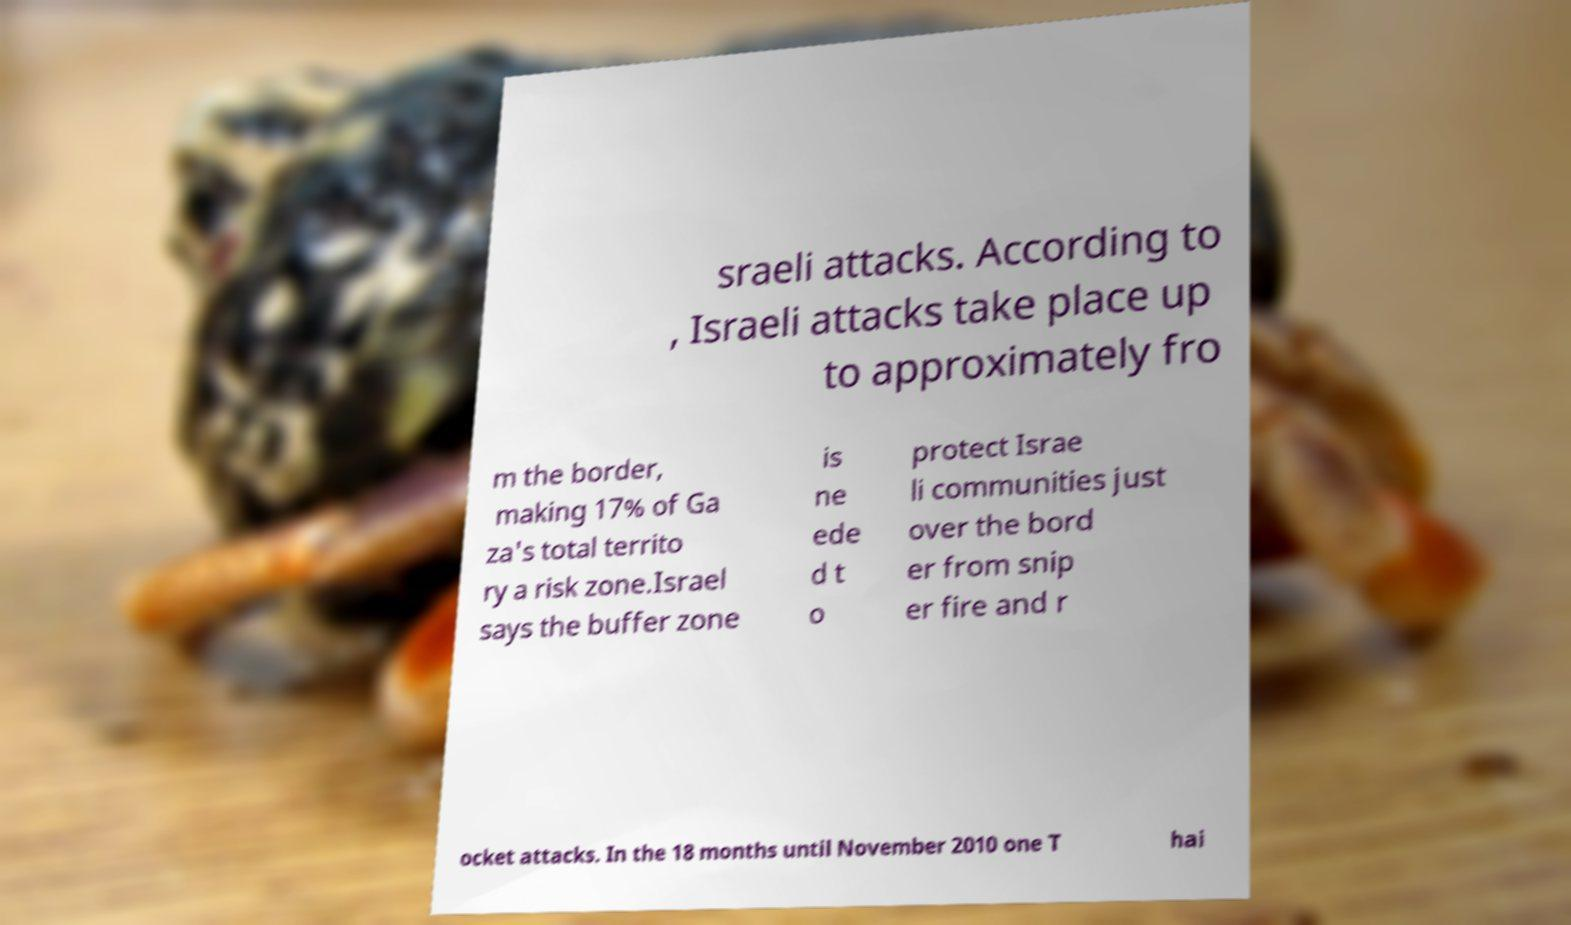For documentation purposes, I need the text within this image transcribed. Could you provide that? sraeli attacks. According to , Israeli attacks take place up to approximately fro m the border, making 17% of Ga za's total territo ry a risk zone.Israel says the buffer zone is ne ede d t o protect Israe li communities just over the bord er from snip er fire and r ocket attacks. In the 18 months until November 2010 one T hai 